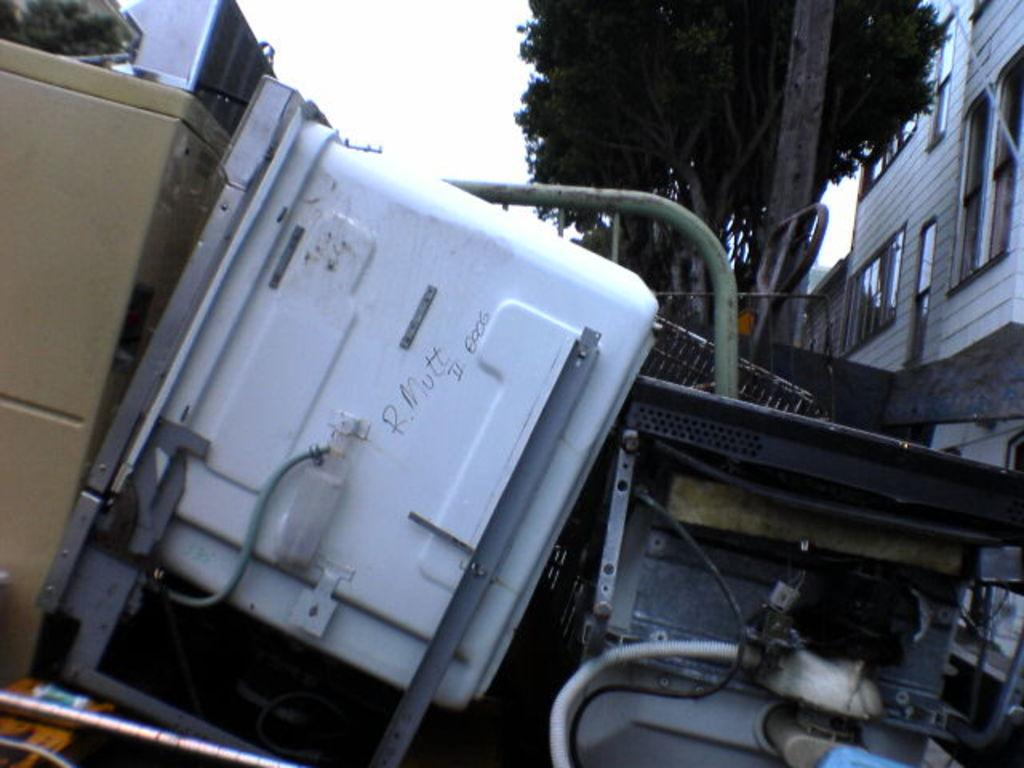Where was the image taken? The image was clicked outside. What can be seen on the right side of the image? There is a building on the right side of the image. What is located at the top of the image? There is a tree at the top of the image. What is in the middle of the image? There is some equipment in the middle of the image. What type of snakes can be seen climbing the tree in the image? There are no snakes present in the image; it features a tree without any animals. What kind of popcorn is being served at the event in the image? There is no event or popcorn present in the image. 